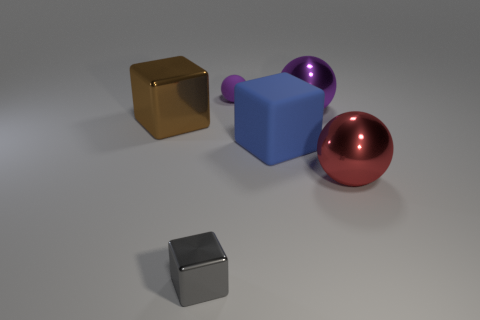Add 1 big green matte balls. How many objects exist? 7 Subtract all tiny green balls. Subtract all purple metal balls. How many objects are left? 5 Add 1 tiny blocks. How many tiny blocks are left? 2 Add 3 blue balls. How many blue balls exist? 3 Subtract 1 blue blocks. How many objects are left? 5 